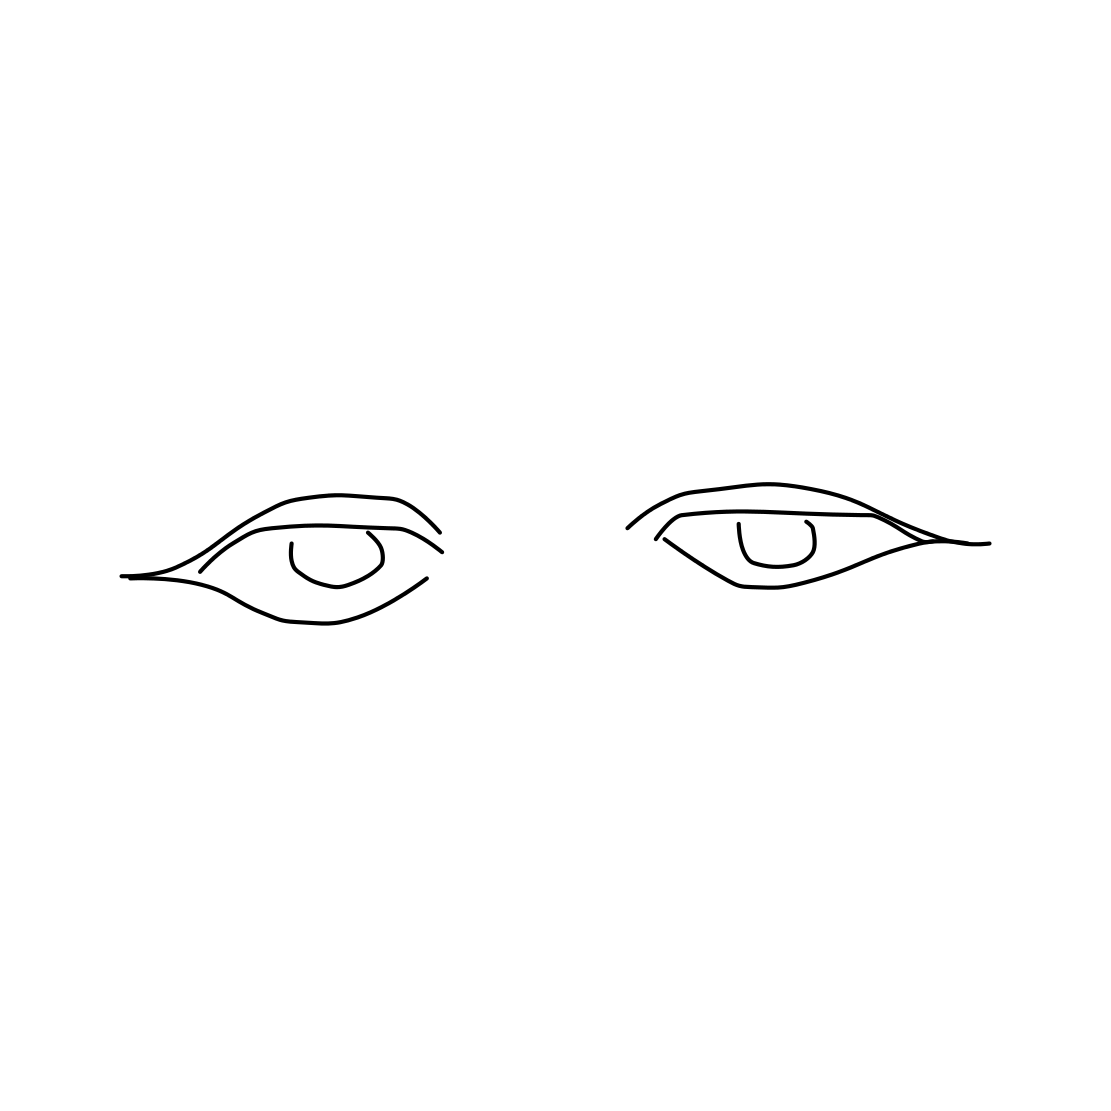What emotion might be conveyed by the eyes in this sketch? The eyes in the sketch have a calm and neutral expression, which could be interpreted as a state of relaxation or contemplation. The lack of strong emotional cues such as furrowed brows or squinted eyes lends to this serene interpretation. 